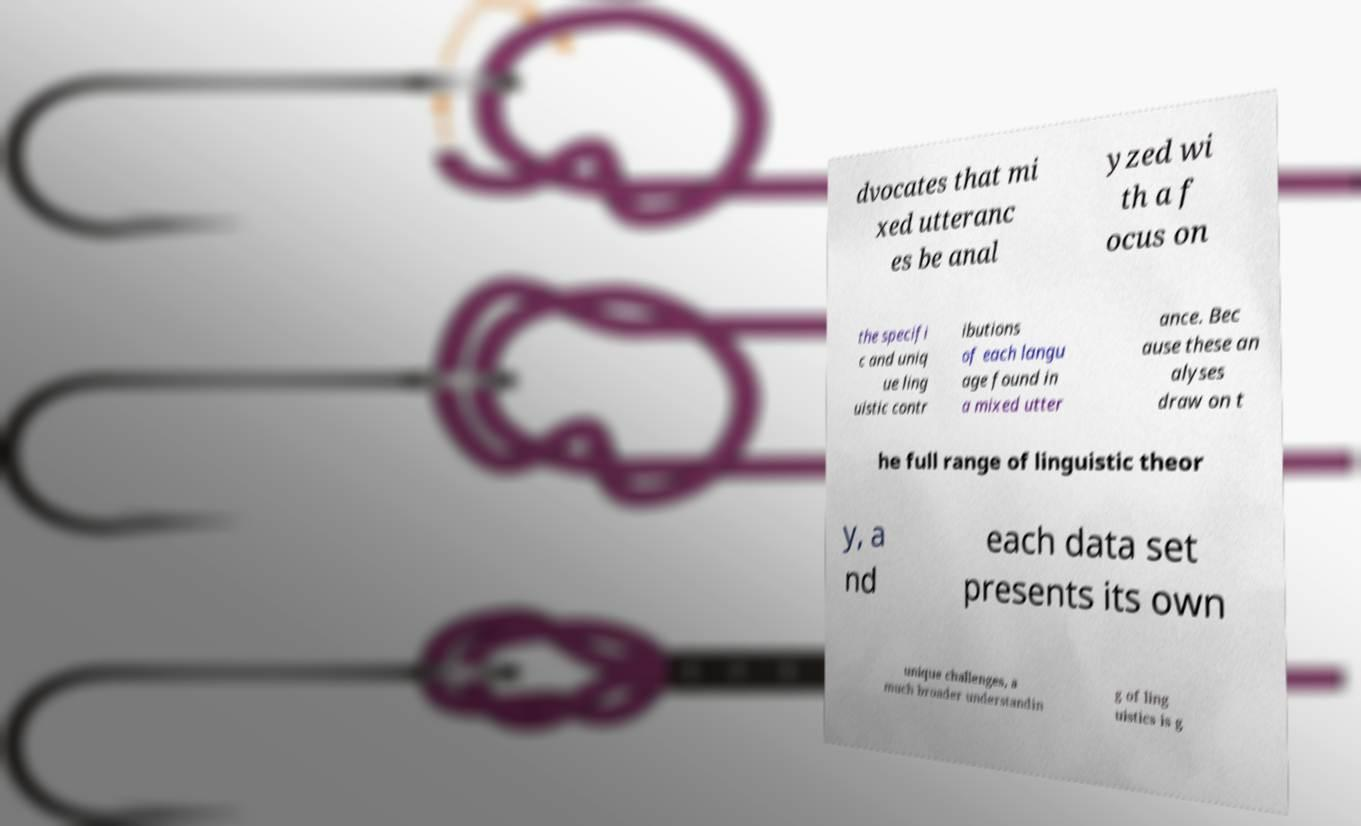What messages or text are displayed in this image? I need them in a readable, typed format. dvocates that mi xed utteranc es be anal yzed wi th a f ocus on the specifi c and uniq ue ling uistic contr ibutions of each langu age found in a mixed utter ance. Bec ause these an alyses draw on t he full range of linguistic theor y, a nd each data set presents its own unique challenges, a much broader understandin g of ling uistics is g 